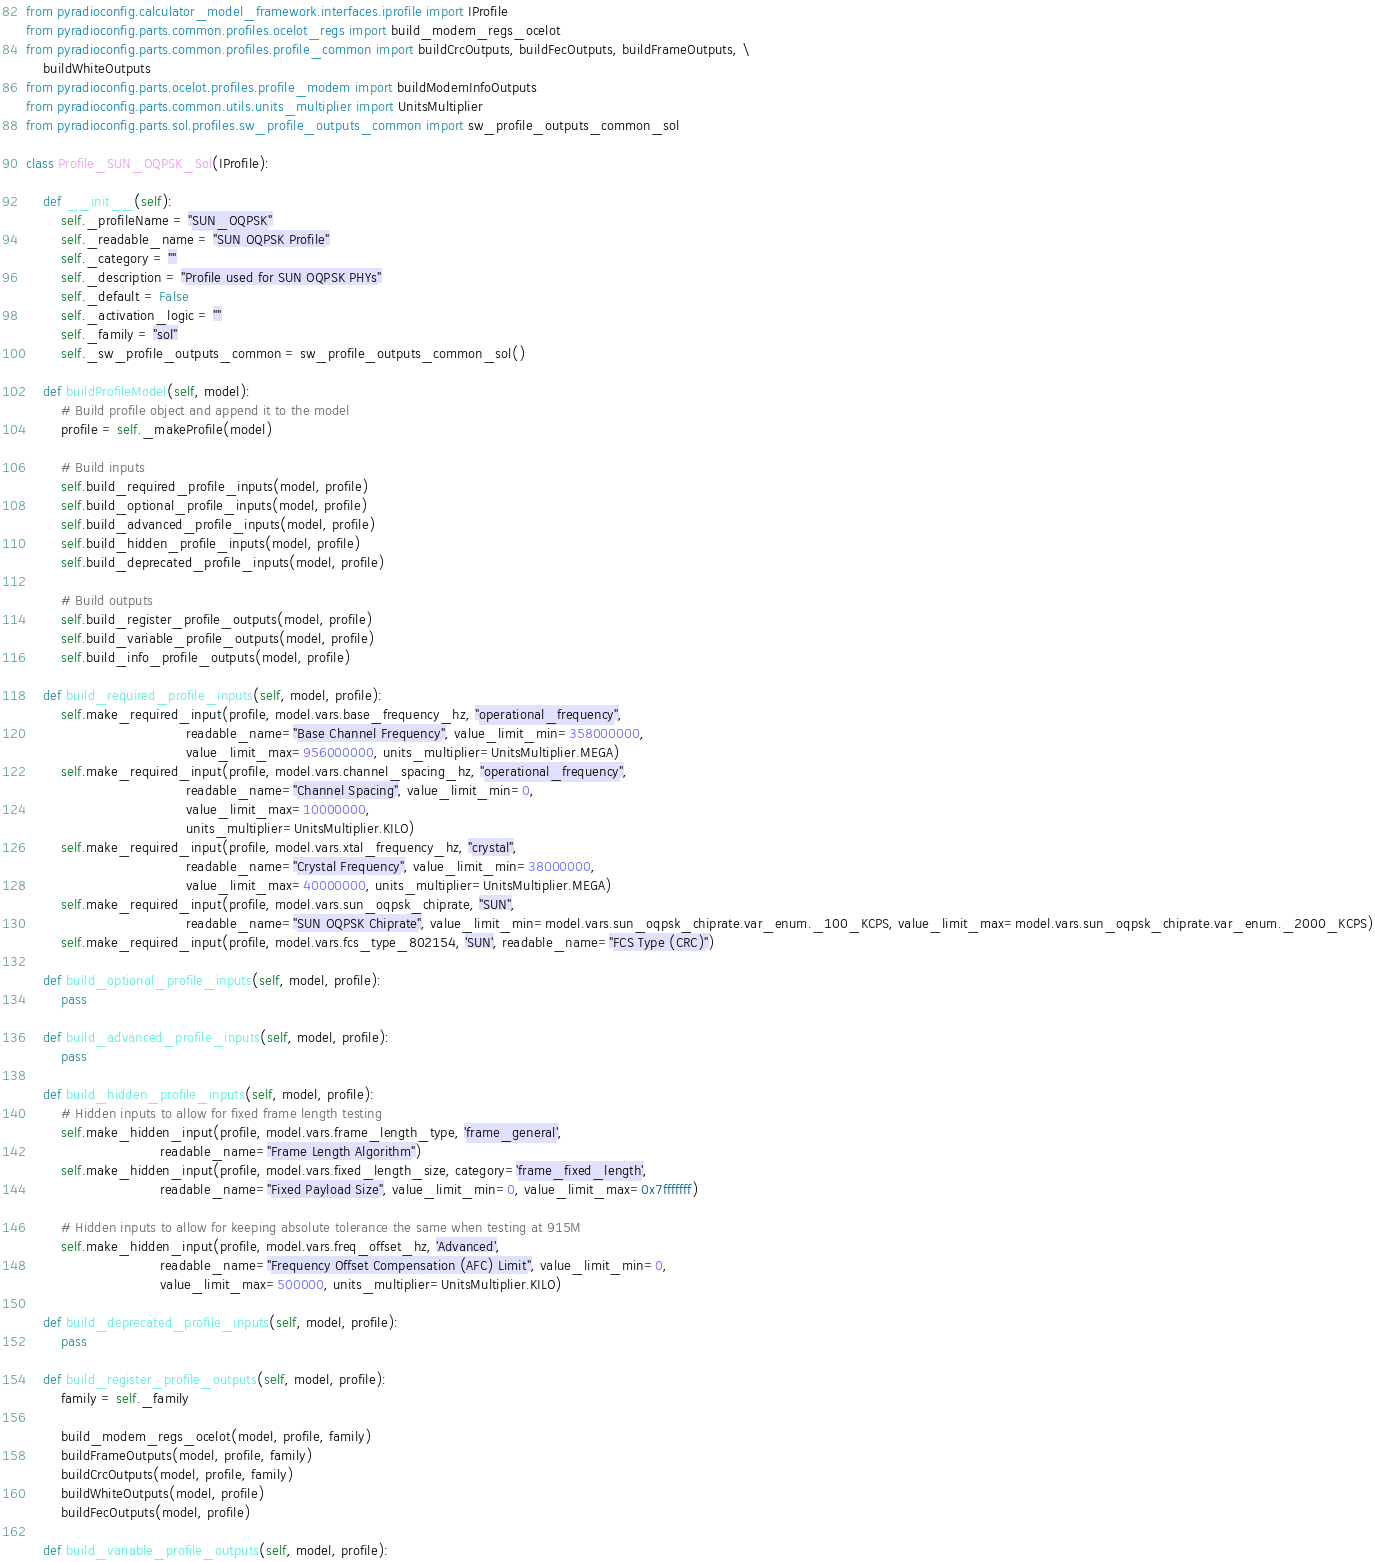<code> <loc_0><loc_0><loc_500><loc_500><_Python_>from pyradioconfig.calculator_model_framework.interfaces.iprofile import IProfile
from pyradioconfig.parts.common.profiles.ocelot_regs import build_modem_regs_ocelot
from pyradioconfig.parts.common.profiles.profile_common import buildCrcOutputs, buildFecOutputs, buildFrameOutputs, \
    buildWhiteOutputs
from pyradioconfig.parts.ocelot.profiles.profile_modem import buildModemInfoOutputs
from pyradioconfig.parts.common.utils.units_multiplier import UnitsMultiplier
from pyradioconfig.parts.sol.profiles.sw_profile_outputs_common import sw_profile_outputs_common_sol

class Profile_SUN_OQPSK_Sol(IProfile):

    def __init__(self):
        self._profileName = "SUN_OQPSK"
        self._readable_name = "SUN OQPSK Profile"
        self._category = ""
        self._description = "Profile used for SUN OQPSK PHYs"
        self._default = False
        self._activation_logic = ""
        self._family = "sol"
        self._sw_profile_outputs_common = sw_profile_outputs_common_sol()

    def buildProfileModel(self, model):
        # Build profile object and append it to the model
        profile = self._makeProfile(model)

        # Build inputs
        self.build_required_profile_inputs(model, profile)
        self.build_optional_profile_inputs(model, profile)
        self.build_advanced_profile_inputs(model, profile)
        self.build_hidden_profile_inputs(model, profile)
        self.build_deprecated_profile_inputs(model, profile)

        # Build outputs
        self.build_register_profile_outputs(model, profile)
        self.build_variable_profile_outputs(model, profile)
        self.build_info_profile_outputs(model, profile)

    def build_required_profile_inputs(self, model, profile):
        self.make_required_input(profile, model.vars.base_frequency_hz, "operational_frequency",
                                     readable_name="Base Channel Frequency", value_limit_min=358000000,
                                     value_limit_max=956000000, units_multiplier=UnitsMultiplier.MEGA)
        self.make_required_input(profile, model.vars.channel_spacing_hz, "operational_frequency",
                                     readable_name="Channel Spacing", value_limit_min=0,
                                     value_limit_max=10000000,
                                     units_multiplier=UnitsMultiplier.KILO)
        self.make_required_input(profile, model.vars.xtal_frequency_hz, "crystal",
                                     readable_name="Crystal Frequency", value_limit_min=38000000,
                                     value_limit_max=40000000, units_multiplier=UnitsMultiplier.MEGA)
        self.make_required_input(profile, model.vars.sun_oqpsk_chiprate, "SUN",
                                     readable_name="SUN OQPSK Chiprate", value_limit_min=model.vars.sun_oqpsk_chiprate.var_enum._100_KCPS, value_limit_max=model.vars.sun_oqpsk_chiprate.var_enum._2000_KCPS)
        self.make_required_input(profile, model.vars.fcs_type_802154, 'SUN', readable_name="FCS Type (CRC)")

    def build_optional_profile_inputs(self, model, profile):
        pass

    def build_advanced_profile_inputs(self, model, profile):
        pass

    def build_hidden_profile_inputs(self, model, profile):
        # Hidden inputs to allow for fixed frame length testing
        self.make_hidden_input(profile, model.vars.frame_length_type, 'frame_general',
                               readable_name="Frame Length Algorithm")
        self.make_hidden_input(profile, model.vars.fixed_length_size, category='frame_fixed_length',
                               readable_name="Fixed Payload Size", value_limit_min=0, value_limit_max=0x7fffffff)

        # Hidden inputs to allow for keeping absolute tolerance the same when testing at 915M
        self.make_hidden_input(profile, model.vars.freq_offset_hz, 'Advanced',
                               readable_name="Frequency Offset Compensation (AFC) Limit", value_limit_min=0,
                               value_limit_max=500000, units_multiplier=UnitsMultiplier.KILO)

    def build_deprecated_profile_inputs(self, model, profile):
        pass

    def build_register_profile_outputs(self, model, profile):
        family = self._family

        build_modem_regs_ocelot(model, profile, family)
        buildFrameOutputs(model, profile, family)
        buildCrcOutputs(model, profile, family)
        buildWhiteOutputs(model, profile)
        buildFecOutputs(model, profile)

    def build_variable_profile_outputs(self, model, profile):</code> 